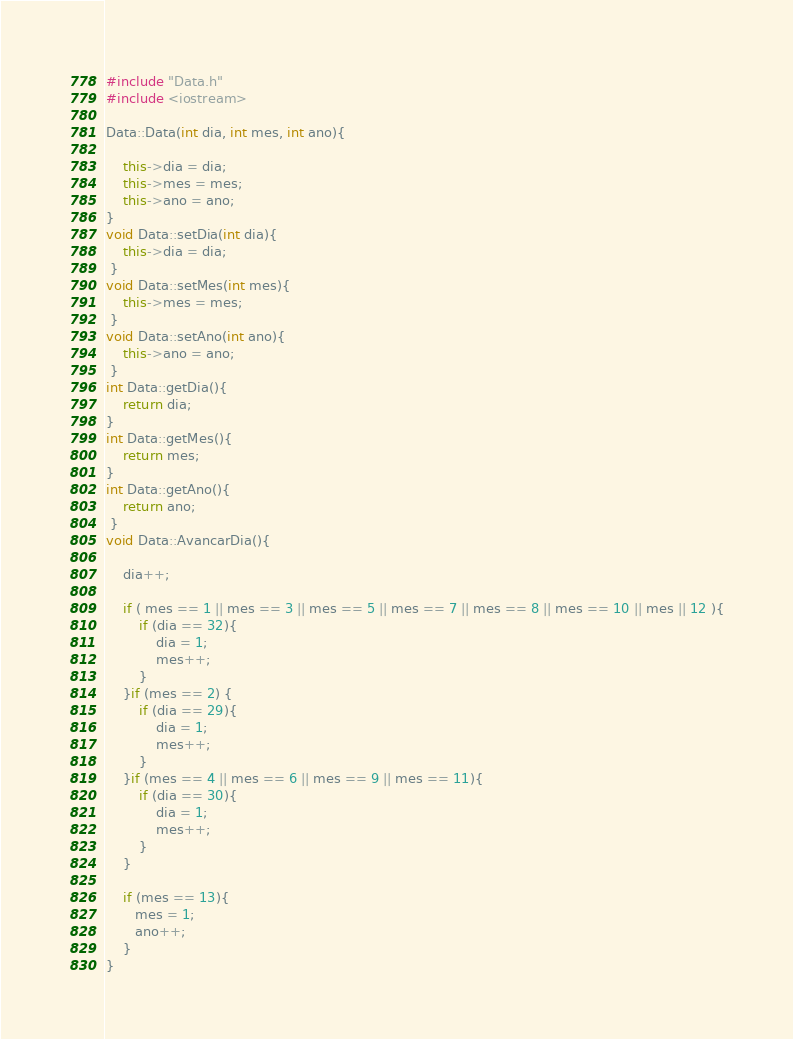<code> <loc_0><loc_0><loc_500><loc_500><_C++_>#include "Data.h"
#include <iostream>

Data::Data(int dia, int mes, int ano){

    this->dia = dia;
    this->mes = mes;
    this->ano = ano;
}
void Data::setDia(int dia){
    this->dia = dia;
 }
void Data::setMes(int mes){
    this->mes = mes;
 }
void Data::setAno(int ano){
    this->ano = ano;
 }
int Data::getDia(){
    return dia;
}
int Data::getMes(){
    return mes;
}
int Data::getAno(){
    return ano;
 }
void Data::AvancarDia(){

    dia++;

    if ( mes == 1 || mes == 3 || mes == 5 || mes == 7 || mes == 8 || mes == 10 || mes || 12 ){
        if (dia == 32){
            dia = 1;
            mes++;
        }
    }if (mes == 2) {
        if (dia == 29){
            dia = 1;
            mes++;
        }
    }if (mes == 4 || mes == 6 || mes == 9 || mes == 11){
        if (dia == 30){
            dia = 1;
            mes++;
        }
    }

    if (mes == 13){
       mes = 1;
       ano++;
    }
}
</code> 